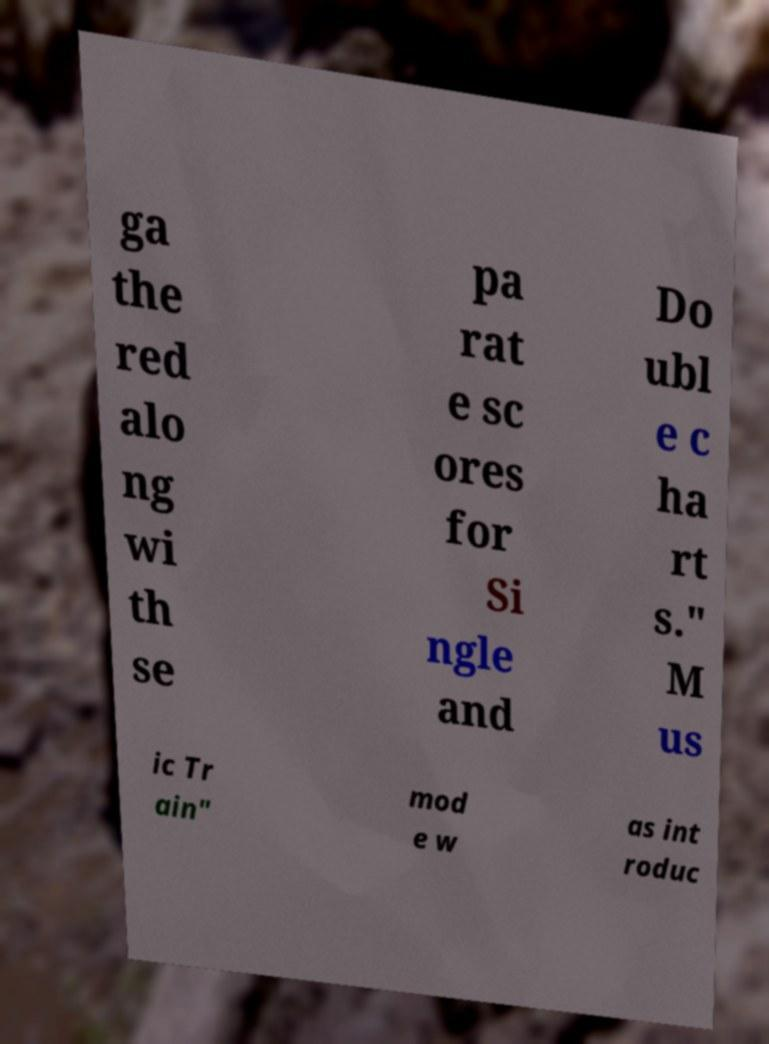There's text embedded in this image that I need extracted. Can you transcribe it verbatim? ga the red alo ng wi th se pa rat e sc ores for Si ngle and Do ubl e c ha rt s." M us ic Tr ain" mod e w as int roduc 